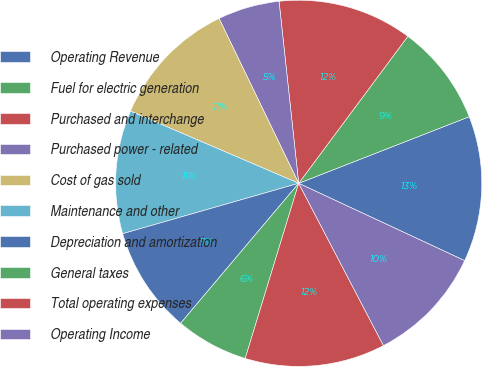Convert chart to OTSL. <chart><loc_0><loc_0><loc_500><loc_500><pie_chart><fcel>Operating Revenue<fcel>Fuel for electric generation<fcel>Purchased and interchange<fcel>Purchased power - related<fcel>Cost of gas sold<fcel>Maintenance and other<fcel>Depreciation and amortization<fcel>General taxes<fcel>Total operating expenses<fcel>Operating Income<nl><fcel>12.87%<fcel>8.91%<fcel>11.88%<fcel>5.45%<fcel>11.39%<fcel>10.89%<fcel>9.41%<fcel>6.44%<fcel>12.38%<fcel>10.4%<nl></chart> 